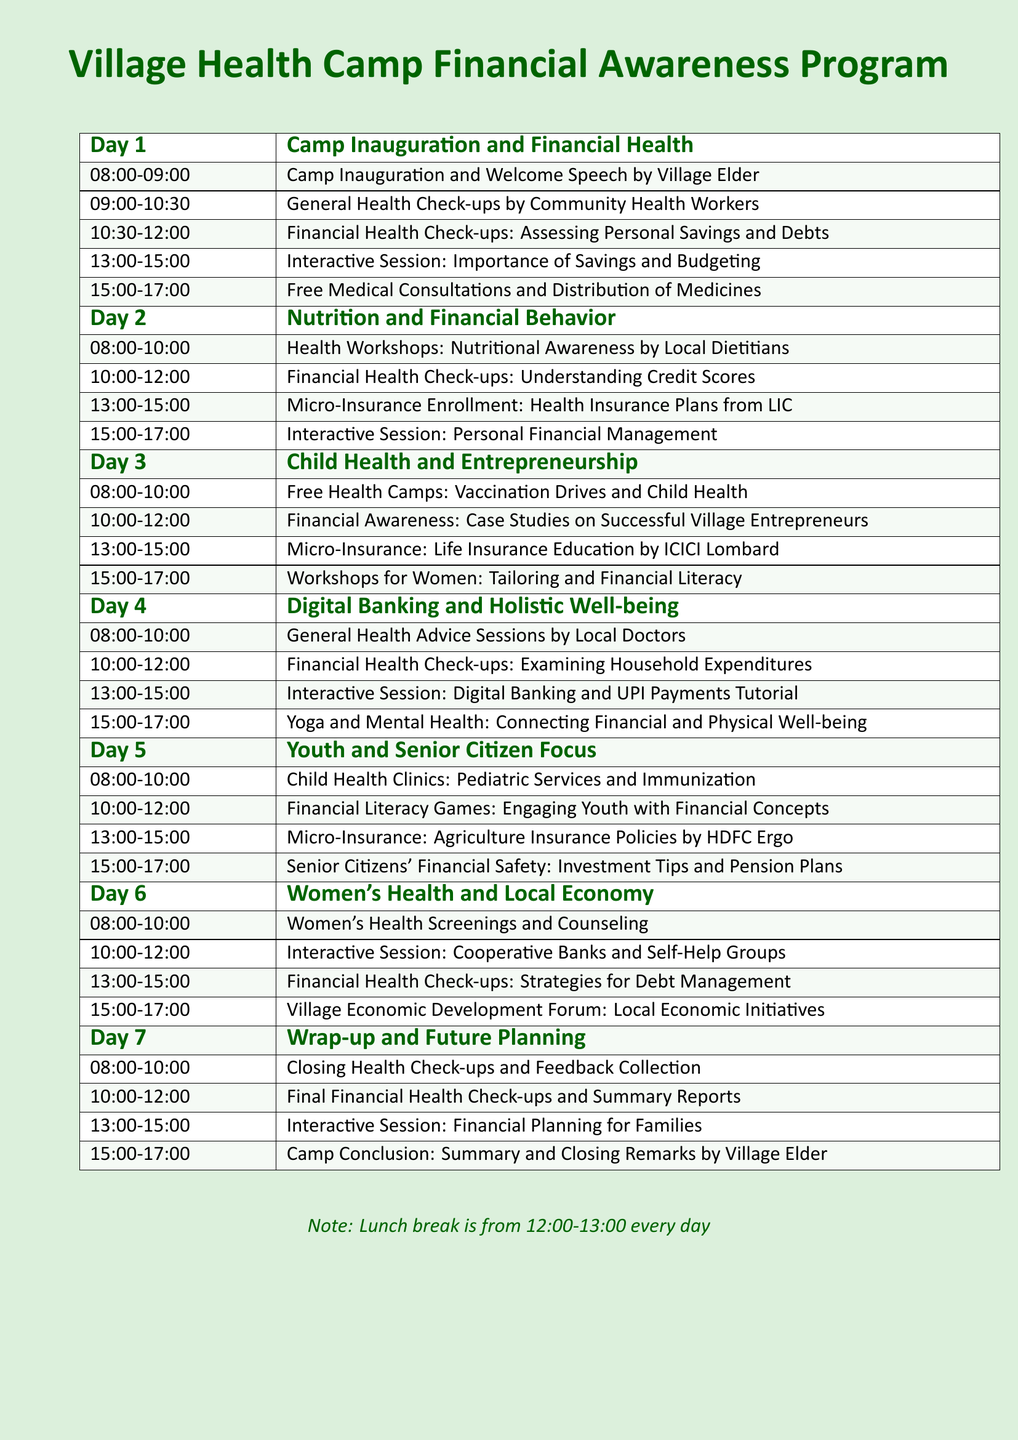What time does the camp inauguration start? The camp inauguration starts at 08:00 on Day 1.
Answer: 08:00 How many days does the health camp last? The health camp is structured to last for a total of 7 days.
Answer: 7 days What is one activity scheduled for Day 3? One activity scheduled for Day 3 is "Free Health Camps: Vaccination Drives and Child Health."
Answer: Free Health Camps: Vaccination Drives and Child Health Which organization is associated with micro-insurance education on Day 3? The organization associated with micro-insurance education on Day 3 is ICICI Lombard.
Answer: ICICI Lombard What activity is scheduled between 13:00 and 15:00 on Day 5? The activity scheduled between 13:00 and 15:00 on Day 5 is "Micro-Insurance: Agriculture Insurance Policies by HDFC Ergo."
Answer: Micro-Insurance: Agriculture Insurance Policies by HDFC Ergo On which day is the focus on Women's Health and Local Economy? The focus on Women's Health and Local Economy is on Day 6.
Answer: Day 6 What is the last activity of the camp on Day 7? The last activity of the camp on Day 7 is "Camp Conclusion: Summary and Closing Remarks by Village Elder."
Answer: Camp Conclusion: Summary and Closing Remarks by Village Elder What is the duration of each financial health check-up session? Each financial health check-up session has a duration of 2 hours.
Answer: 2 hours 